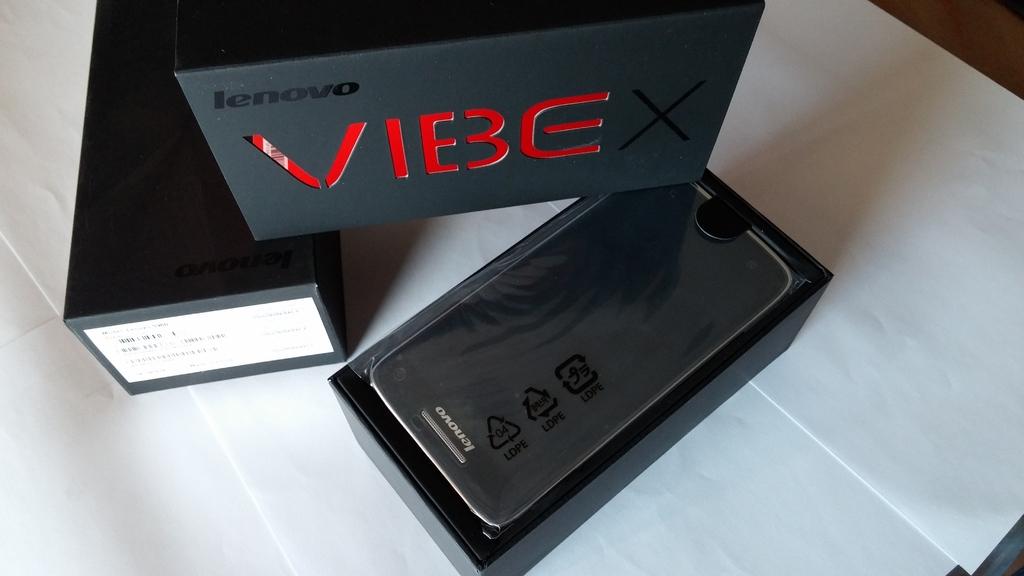What brand phone is this?
Offer a terse response. Lenovo. What color is vibe written in?
Give a very brief answer. Red. 